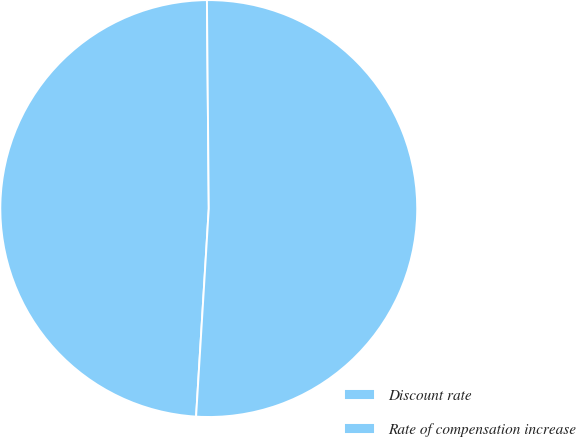Convert chart to OTSL. <chart><loc_0><loc_0><loc_500><loc_500><pie_chart><fcel>Discount rate<fcel>Rate of compensation increase<nl><fcel>48.89%<fcel>51.11%<nl></chart> 